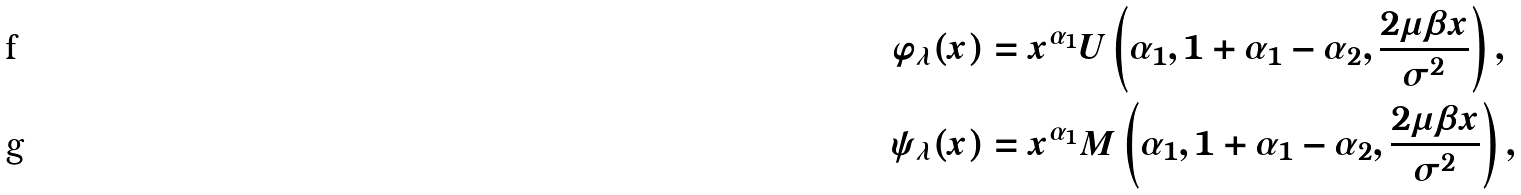Convert formula to latex. <formula><loc_0><loc_0><loc_500><loc_500>\varphi _ { \lambda } ( x ) & = x ^ { \alpha _ { 1 } } U \left ( \alpha _ { 1 } , 1 + \alpha _ { 1 } - \alpha _ { 2 } , \frac { 2 \mu \beta x } { \sigma ^ { 2 } } \right ) , \\ \quad \psi _ { \lambda } ( x ) & = x ^ { \alpha _ { 1 } } M \left ( \alpha _ { 1 } , 1 + \alpha _ { 1 } - \alpha _ { 2 } , \frac { 2 \mu \beta x } { \sigma ^ { 2 } } \right ) ,</formula> 